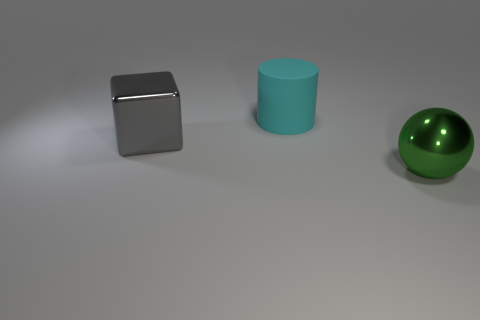Is there any other thing that has the same material as the big cyan cylinder?
Provide a succinct answer. No. What shape is the object behind the large metallic thing on the left side of the large green metal ball?
Keep it short and to the point. Cylinder. How many green balls are to the right of the big thing to the left of the big cyan object?
Keep it short and to the point. 1. What material is the big thing that is both right of the gray object and behind the green metallic sphere?
Offer a very short reply. Rubber. The cyan matte object that is the same size as the gray thing is what shape?
Provide a short and direct response. Cylinder. What is the color of the large metallic object that is on the left side of the big metal sphere on the right side of the large object behind the gray shiny object?
Your answer should be very brief. Gray. What number of things are metallic objects that are on the left side of the large green metal thing or small green metallic cubes?
Your answer should be very brief. 1. There is a cylinder that is the same size as the ball; what is its material?
Make the answer very short. Rubber. What is the material of the thing behind the metallic thing that is behind the large metallic thing that is in front of the shiny cube?
Your answer should be compact. Rubber. What is the color of the big metal cube?
Keep it short and to the point. Gray. 